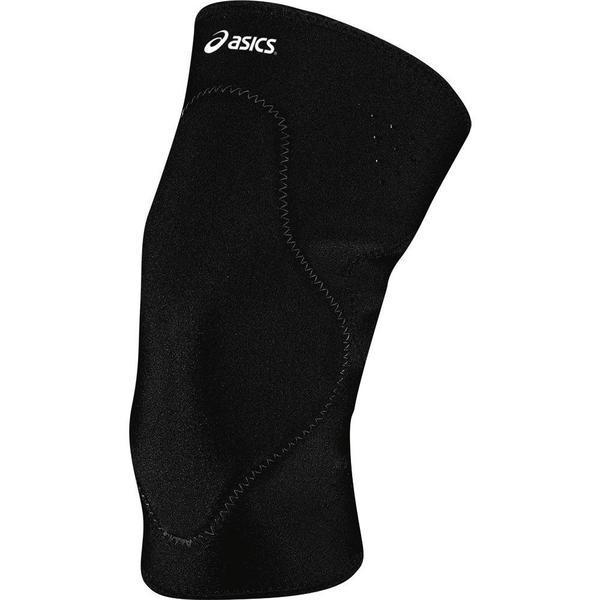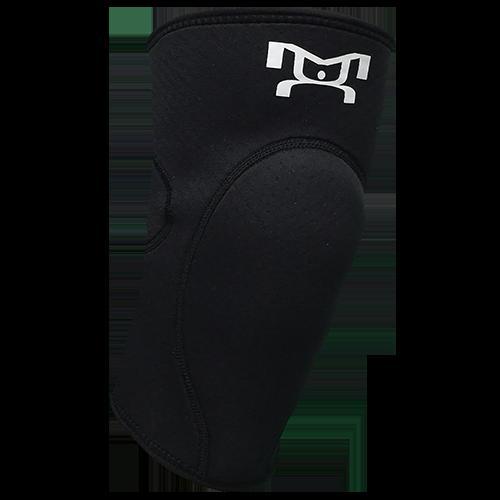The first image is the image on the left, the second image is the image on the right. Examine the images to the left and right. Is the description "Left image features one right-facing kneepad." accurate? Answer yes or no. No. 